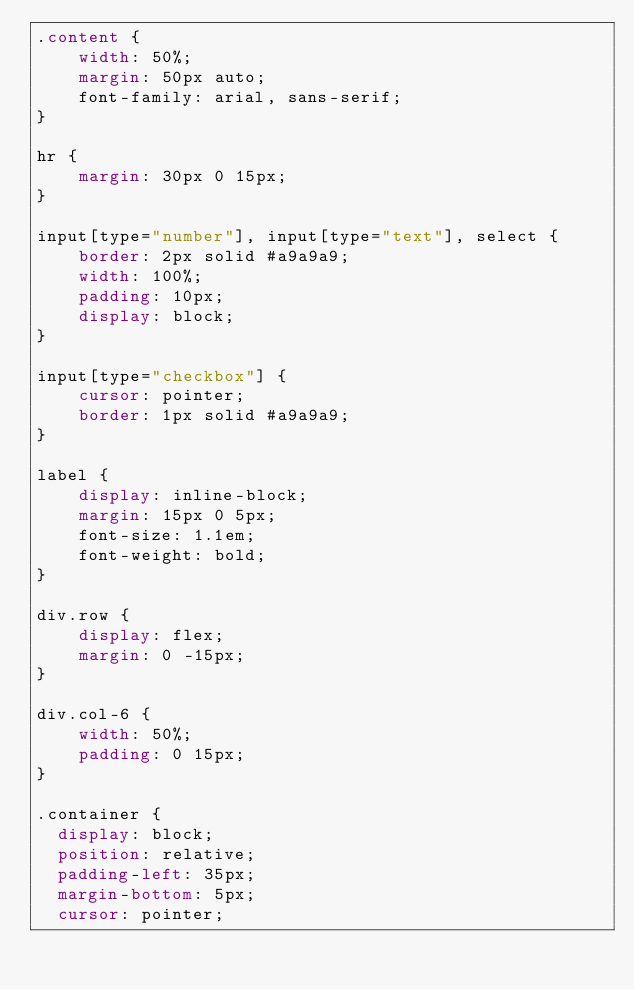<code> <loc_0><loc_0><loc_500><loc_500><_CSS_>.content {
    width: 50%;
    margin: 50px auto;
    font-family: arial, sans-serif;
}

hr {
    margin: 30px 0 15px;
}

input[type="number"], input[type="text"], select {
    border: 2px solid #a9a9a9;
    width: 100%;
    padding: 10px;
    display: block;
}

input[type="checkbox"] {
    cursor: pointer;
    border: 1px solid #a9a9a9;
}

label {
    display: inline-block;
    margin: 15px 0 5px;
    font-size: 1.1em;
    font-weight: bold;
}

div.row {
    display: flex;
    margin: 0 -15px;
}

div.col-6 {
    width: 50%;
    padding: 0 15px;
}

.container {
  display: block;
  position: relative;
  padding-left: 35px;
  margin-bottom: 5px;
  cursor: pointer;</code> 